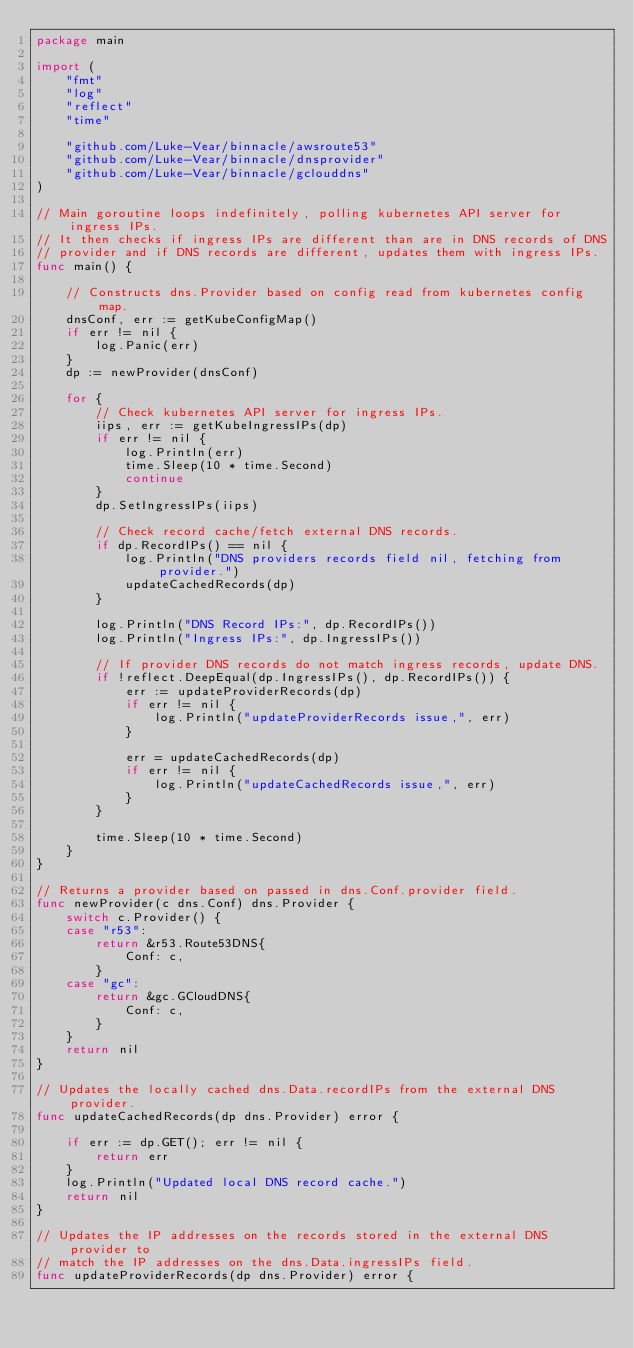Convert code to text. <code><loc_0><loc_0><loc_500><loc_500><_Go_>package main

import (
	"fmt"
	"log"
	"reflect"
	"time"

	"github.com/Luke-Vear/binnacle/awsroute53"
	"github.com/Luke-Vear/binnacle/dnsprovider"
	"github.com/Luke-Vear/binnacle/gclouddns"
)

// Main goroutine loops indefinitely, polling kubernetes API server for ingress IPs.
// It then checks if ingress IPs are different than are in DNS records of DNS
// provider and if DNS records are different, updates them with ingress IPs.
func main() {

	// Constructs dns.Provider based on config read from kubernetes config map.
	dnsConf, err := getKubeConfigMap()
	if err != nil {
		log.Panic(err)
	}
	dp := newProvider(dnsConf)

	for {
		// Check kubernetes API server for ingress IPs.
		iips, err := getKubeIngressIPs(dp)
		if err != nil {
			log.Println(err)
			time.Sleep(10 * time.Second)
			continue
		}
		dp.SetIngressIPs(iips)

		// Check record cache/fetch external DNS records.
		if dp.RecordIPs() == nil {
			log.Println("DNS providers records field nil, fetching from provider.")
			updateCachedRecords(dp)
		}

		log.Println("DNS Record IPs:", dp.RecordIPs())
		log.Println("Ingress IPs:", dp.IngressIPs())

		// If provider DNS records do not match ingress records, update DNS.
		if !reflect.DeepEqual(dp.IngressIPs(), dp.RecordIPs()) {
			err := updateProviderRecords(dp)
			if err != nil {
				log.Println("updateProviderRecords issue,", err)
			}

			err = updateCachedRecords(dp)
			if err != nil {
				log.Println("updateCachedRecords issue,", err)
			}
		}

		time.Sleep(10 * time.Second)
	}
}

// Returns a provider based on passed in dns.Conf.provider field.
func newProvider(c dns.Conf) dns.Provider {
	switch c.Provider() {
	case "r53":
		return &r53.Route53DNS{
			Conf: c,
		}
	case "gc":
		return &gc.GCloudDNS{
			Conf: c,
		}
	}
	return nil
}

// Updates the locally cached dns.Data.recordIPs from the external DNS provider.
func updateCachedRecords(dp dns.Provider) error {

	if err := dp.GET(); err != nil {
		return err
	}
	log.Println("Updated local DNS record cache.")
	return nil
}

// Updates the IP addresses on the records stored in the external DNS provider to
// match the IP addresses on the dns.Data.ingressIPs field.
func updateProviderRecords(dp dns.Provider) error {
</code> 